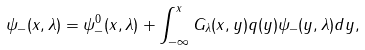Convert formula to latex. <formula><loc_0><loc_0><loc_500><loc_500>\psi _ { - } ( x , { \lambda } ) = \psi _ { - } ^ { 0 } ( x , { \lambda } ) + \int _ { - \infty } ^ { x } G _ { \lambda } ( x , y ) q ( y ) \psi _ { - } ( y , { \lambda } ) d y ,</formula> 